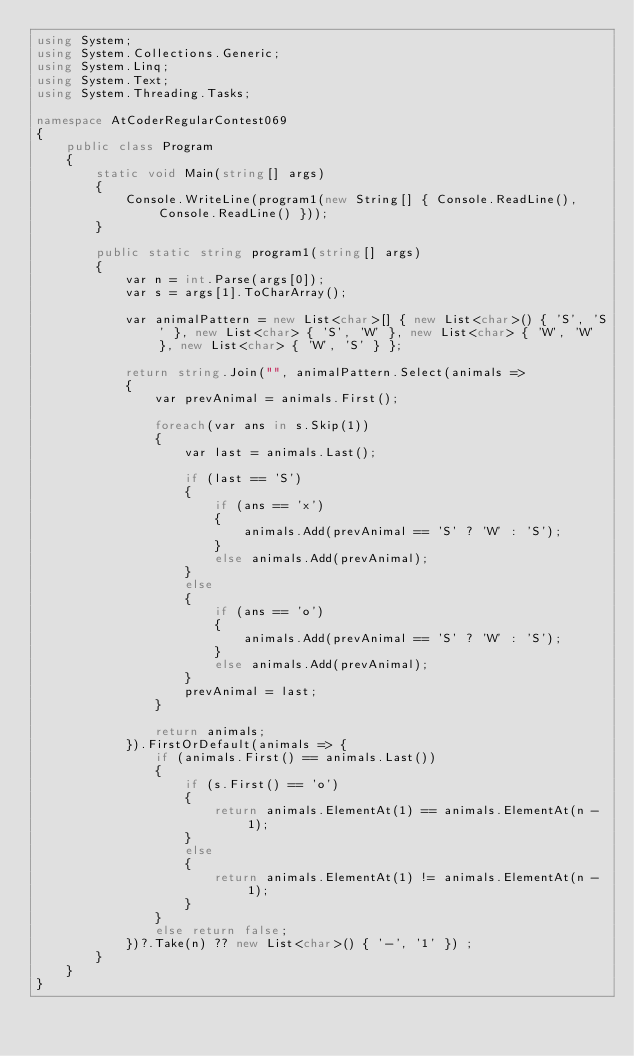Convert code to text. <code><loc_0><loc_0><loc_500><loc_500><_C#_>using System;
using System.Collections.Generic;
using System.Linq;
using System.Text;
using System.Threading.Tasks;

namespace AtCoderRegularContest069
{
    public class Program
    {
        static void Main(string[] args)
        {
            Console.WriteLine(program1(new String[] { Console.ReadLine(), Console.ReadLine() }));
        }

        public static string program1(string[] args)
        {
            var n = int.Parse(args[0]);
            var s = args[1].ToCharArray();

            var animalPattern = new List<char>[] { new List<char>() { 'S', 'S' }, new List<char> { 'S', 'W' }, new List<char> { 'W', 'W' }, new List<char> { 'W', 'S' } };

            return string.Join("", animalPattern.Select(animals =>
            {
                var prevAnimal = animals.First();
                             
                foreach(var ans in s.Skip(1))
                {
                    var last = animals.Last();

                    if (last == 'S')
                    {
                        if (ans == 'x')
                        {
                            animals.Add(prevAnimal == 'S' ? 'W' : 'S');
                        }
                        else animals.Add(prevAnimal);
                    }
                    else
                    {
                        if (ans == 'o')
                        {
                            animals.Add(prevAnimal == 'S' ? 'W' : 'S');
                        }
                        else animals.Add(prevAnimal);
                    }
                    prevAnimal = last;
                }

                return animals;
            }).FirstOrDefault(animals => {
                if (animals.First() == animals.Last())
                {
                    if (s.First() == 'o')
                    {
                        return animals.ElementAt(1) == animals.ElementAt(n - 1);
                    }
                    else
                    {
                        return animals.ElementAt(1) != animals.ElementAt(n - 1);
                    }
                }
                else return false;
            })?.Take(n) ?? new List<char>() { '-', '1' }) ;
        }
    }
}
</code> 